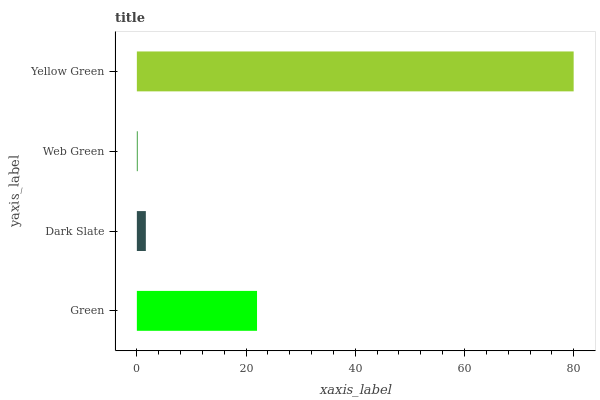Is Web Green the minimum?
Answer yes or no. Yes. Is Yellow Green the maximum?
Answer yes or no. Yes. Is Dark Slate the minimum?
Answer yes or no. No. Is Dark Slate the maximum?
Answer yes or no. No. Is Green greater than Dark Slate?
Answer yes or no. Yes. Is Dark Slate less than Green?
Answer yes or no. Yes. Is Dark Slate greater than Green?
Answer yes or no. No. Is Green less than Dark Slate?
Answer yes or no. No. Is Green the high median?
Answer yes or no. Yes. Is Dark Slate the low median?
Answer yes or no. Yes. Is Yellow Green the high median?
Answer yes or no. No. Is Yellow Green the low median?
Answer yes or no. No. 